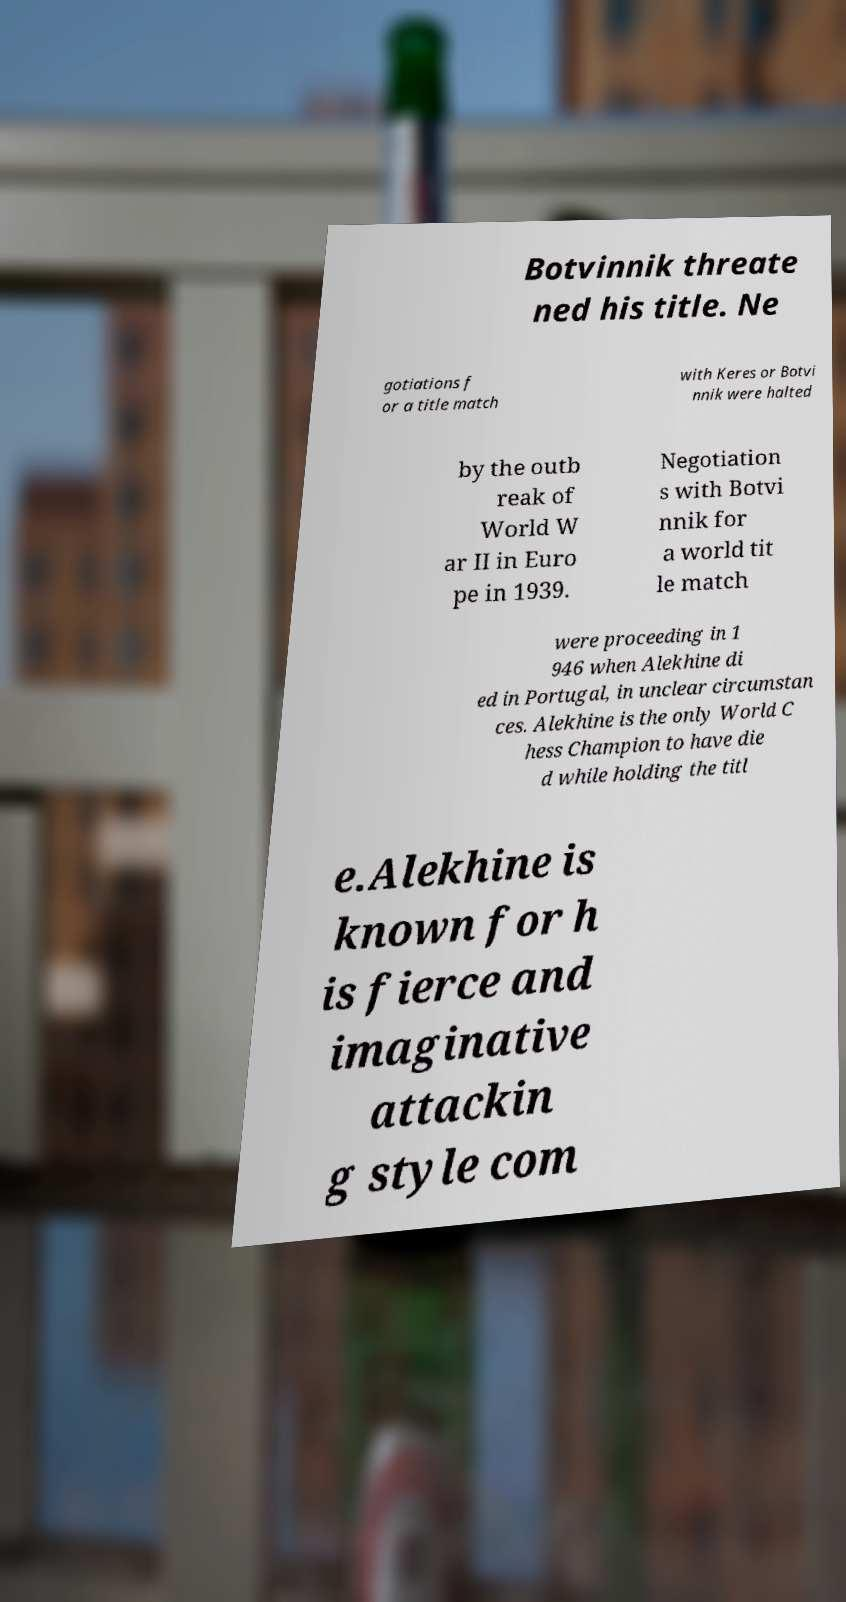Can you read and provide the text displayed in the image?This photo seems to have some interesting text. Can you extract and type it out for me? Botvinnik threate ned his title. Ne gotiations f or a title match with Keres or Botvi nnik were halted by the outb reak of World W ar II in Euro pe in 1939. Negotiation s with Botvi nnik for a world tit le match were proceeding in 1 946 when Alekhine di ed in Portugal, in unclear circumstan ces. Alekhine is the only World C hess Champion to have die d while holding the titl e.Alekhine is known for h is fierce and imaginative attackin g style com 